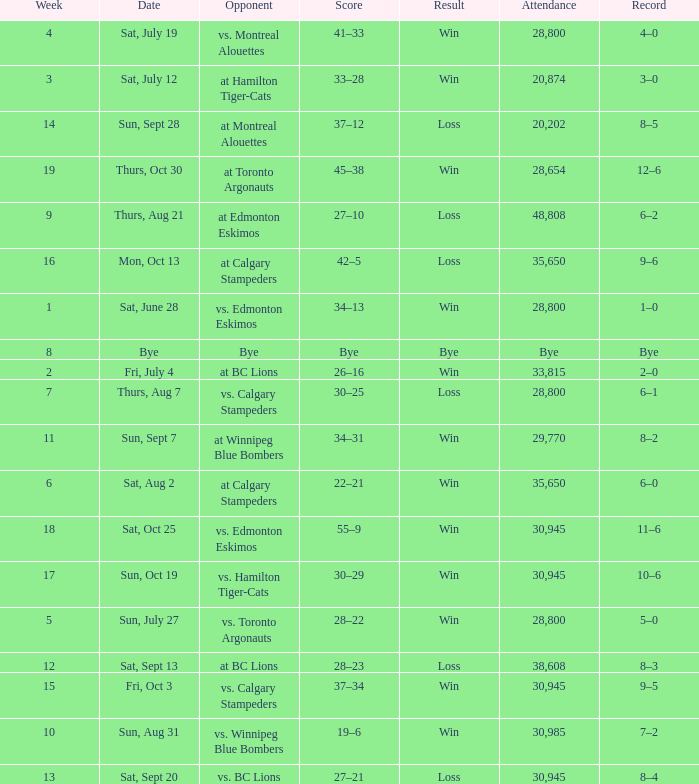What was the date of the game with an attendance of 20,874 fans? Sat, July 12. 